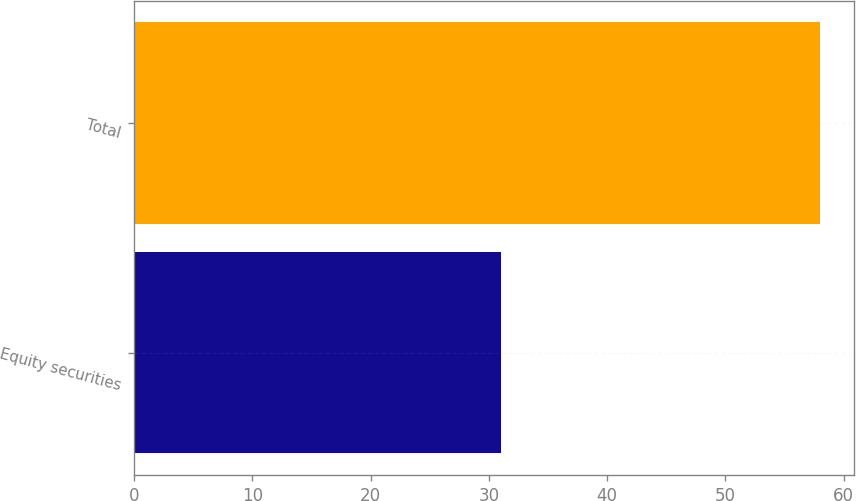Convert chart. <chart><loc_0><loc_0><loc_500><loc_500><bar_chart><fcel>Equity securities<fcel>Total<nl><fcel>31<fcel>58<nl></chart> 